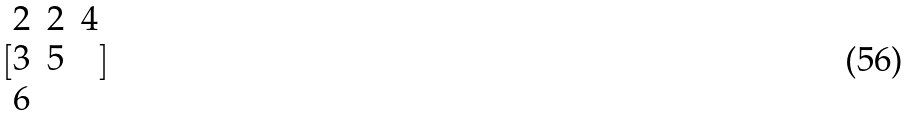<formula> <loc_0><loc_0><loc_500><loc_500>[ \begin{matrix} 2 & 2 & 4 \\ 3 & 5 \\ 6 \end{matrix} ]</formula> 